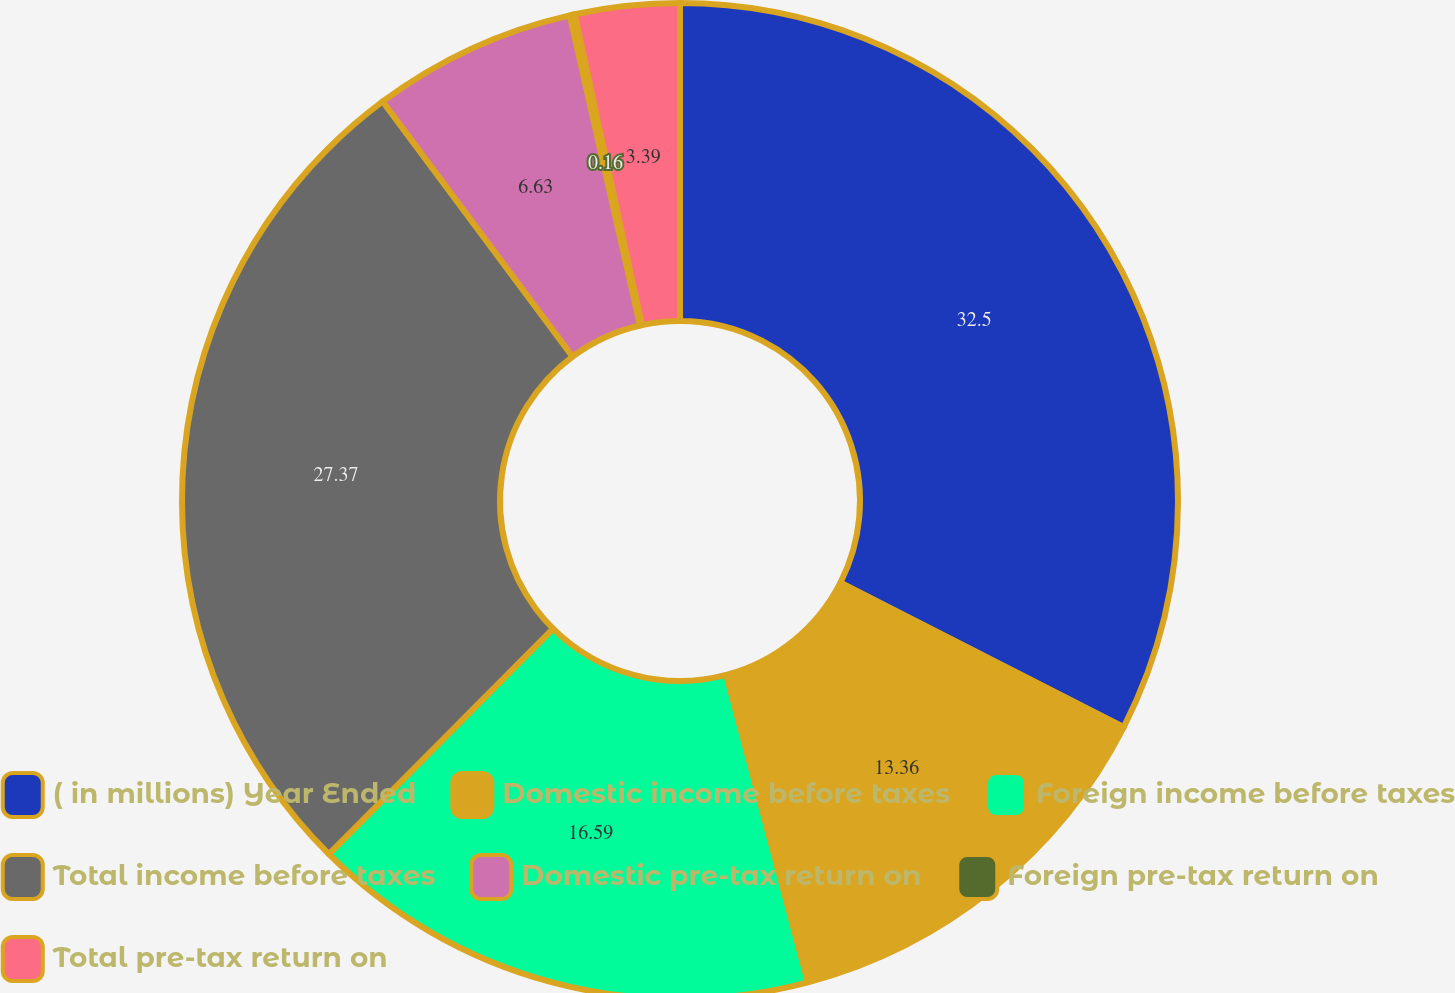<chart> <loc_0><loc_0><loc_500><loc_500><pie_chart><fcel>( in millions) Year Ended<fcel>Domestic income before taxes<fcel>Foreign income before taxes<fcel>Total income before taxes<fcel>Domestic pre-tax return on<fcel>Foreign pre-tax return on<fcel>Total pre-tax return on<nl><fcel>32.51%<fcel>13.36%<fcel>16.59%<fcel>27.37%<fcel>6.63%<fcel>0.16%<fcel>3.39%<nl></chart> 